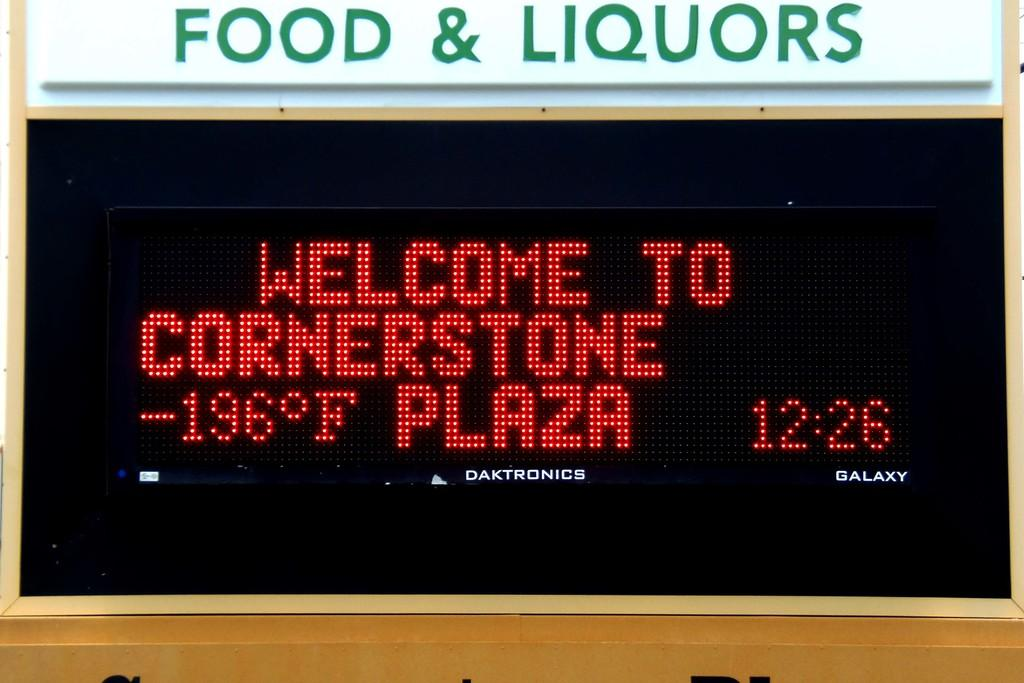<image>
Give a short and clear explanation of the subsequent image. The display on a plaza information display lists the temperature as -196 degrees Fahrenheit. 